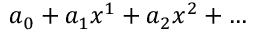Convert formula to latex. <formula><loc_0><loc_0><loc_500><loc_500>a _ { 0 } + a _ { 1 } x ^ { 1 } + a _ { 2 } x ^ { 2 } + \dots</formula> 